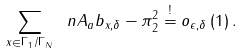<formula> <loc_0><loc_0><loc_500><loc_500>\sum _ { x \in \Gamma _ { 1 } / \Gamma _ { N } } \ n { A _ { a } b _ { x , \delta } - \pi } _ { 2 } ^ { 2 } \overset { ! } { = } o _ { \epsilon , \delta } \left ( 1 \right ) .</formula> 